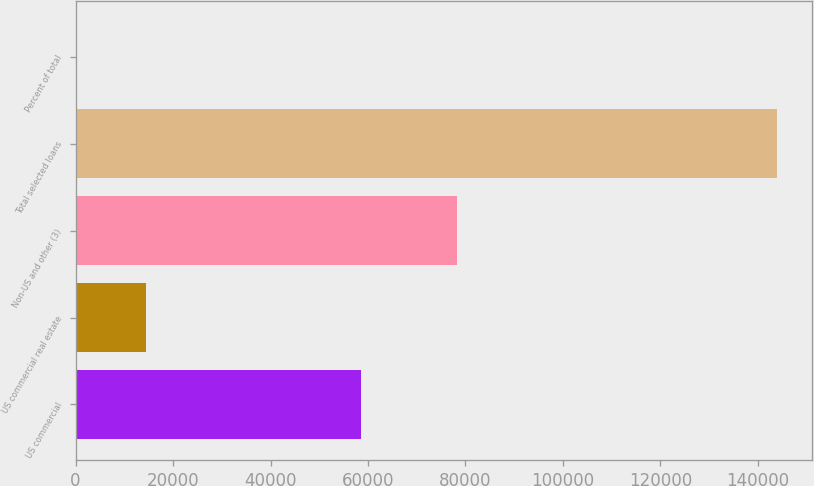<chart> <loc_0><loc_0><loc_500><loc_500><bar_chart><fcel>US commercial<fcel>US commercial real estate<fcel>Non-US and other (3)<fcel>Total selected loans<fcel>Percent of total<nl><fcel>58522<fcel>14431.8<fcel>78201<fcel>143967<fcel>39<nl></chart> 